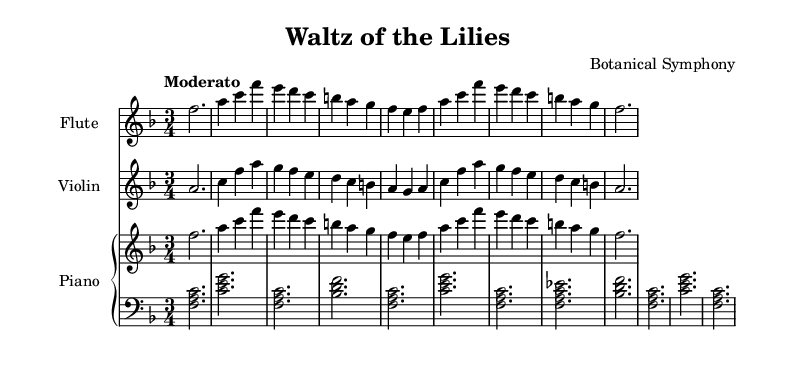What is the key signature of this music? The key signature is F major, which has one flat (B flat). This is indicated at the beginning of the sheet music with the flat sign next to the B note.
Answer: F major What is the time signature of this music? The time signature is 3/4, meaning there are three beats in each measure, and the quarter note gets one beat. This is shown just after the key signature.
Answer: 3/4 What is the tempo marking? The tempo marking is "Moderato," which indicates a moderate speed for the performance. This is specified at the beginning of the sheet music.
Answer: Moderato How many measures are in the flute part? The flute part consists of eight measures. By counting the measure lines in the flute staff, we can determine the total number of measures.
Answer: 8 What type of piece is "Waltz of the Lilies"? The piece is a waltz, which is characterized by its 3/4 time signature and typically flowing, dance-like rhythms. This can be inferred from the title and time signature.
Answer: Waltz Which instrument has the melody in this score? The flute has the melody in this score, as it plays the primary thematic material that is easily recognizable as the main tune throughout the piece.
Answer: Flute 